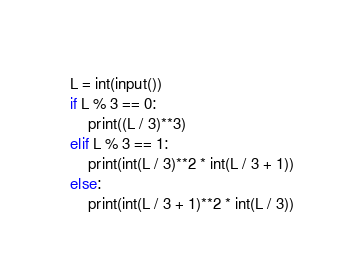Convert code to text. <code><loc_0><loc_0><loc_500><loc_500><_Python_>L = int(input())
if L % 3 == 0:
    print((L / 3)**3)
elif L % 3 == 1:
    print(int(L / 3)**2 * int(L / 3 + 1))
else:
    print(int(L / 3 + 1)**2 * int(L / 3))
</code> 